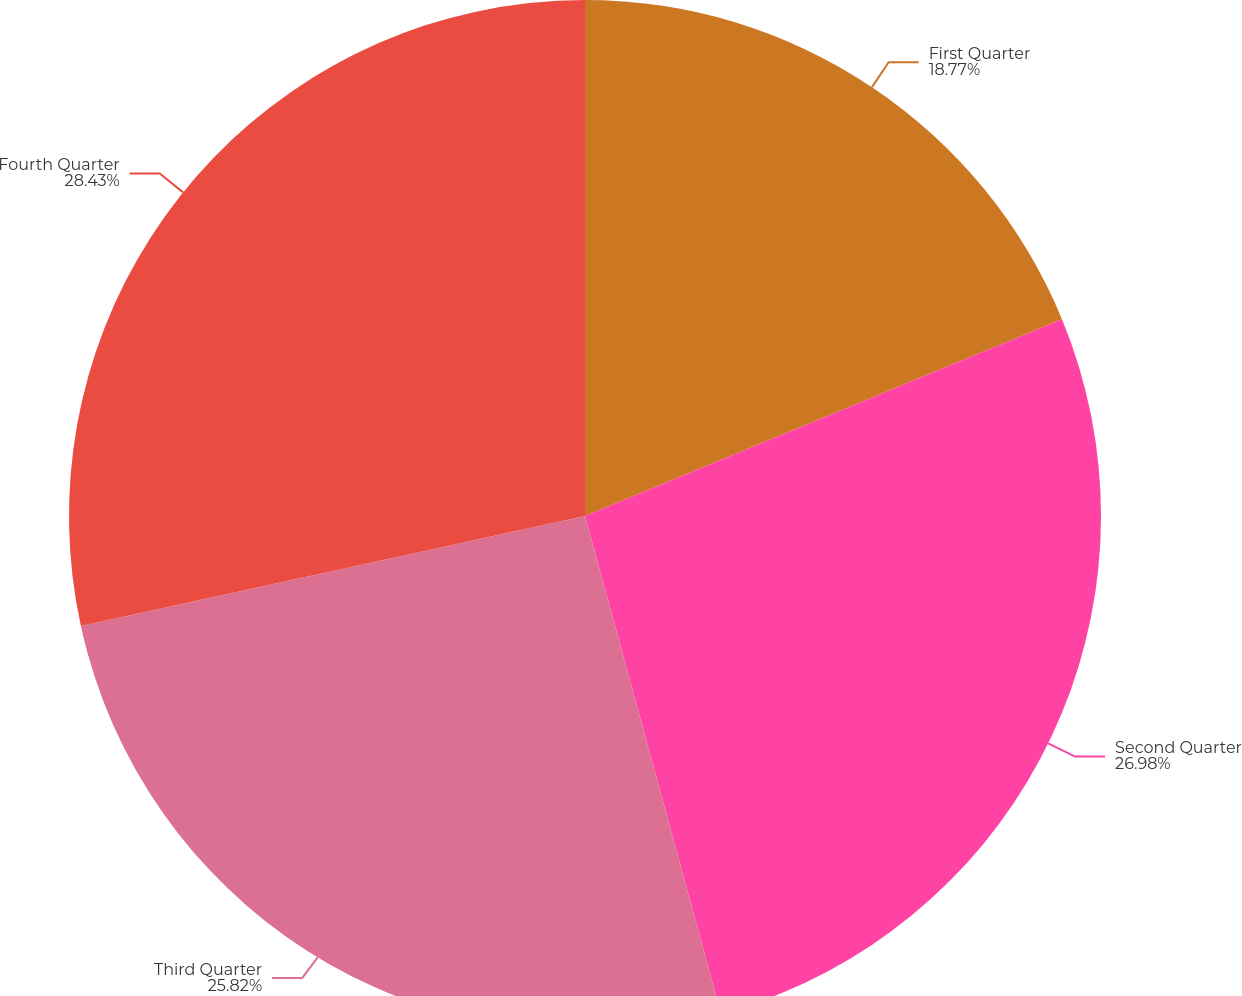Convert chart. <chart><loc_0><loc_0><loc_500><loc_500><pie_chart><fcel>First Quarter<fcel>Second Quarter<fcel>Third Quarter<fcel>Fourth Quarter<nl><fcel>18.77%<fcel>26.98%<fcel>25.82%<fcel>28.42%<nl></chart> 